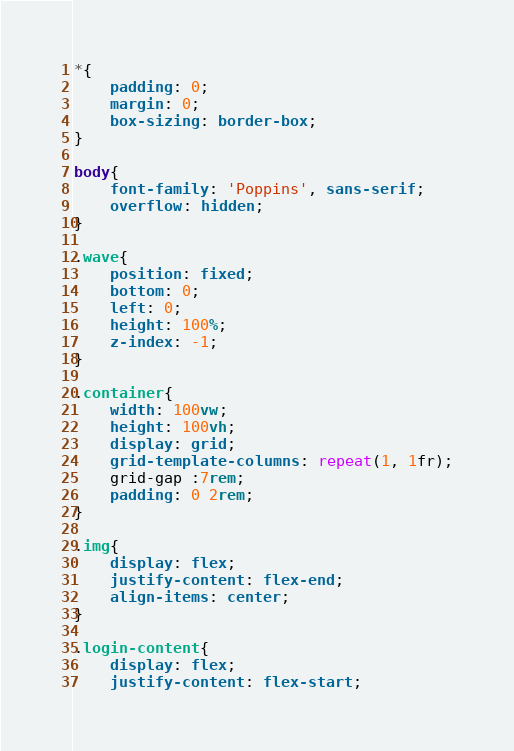Convert code to text. <code><loc_0><loc_0><loc_500><loc_500><_CSS_>*{
	padding: 0;
	margin: 0;
	box-sizing: border-box;
}

body{
    font-family: 'Poppins', sans-serif;
    overflow: hidden;
}

.wave{
	position: fixed;
	bottom: 0;
	left: 0;
	height: 100%;
	z-index: -1;
}

.container{
    width: 100vw;
    height: 100vh;
    display: grid;
    grid-template-columns: repeat(1, 1fr);
    grid-gap :7rem;
    padding: 0 2rem;
}

.img{
	display: flex;
	justify-content: flex-end;
	align-items: center;
}

.login-content{
	display: flex;
	justify-content: flex-start;</code> 